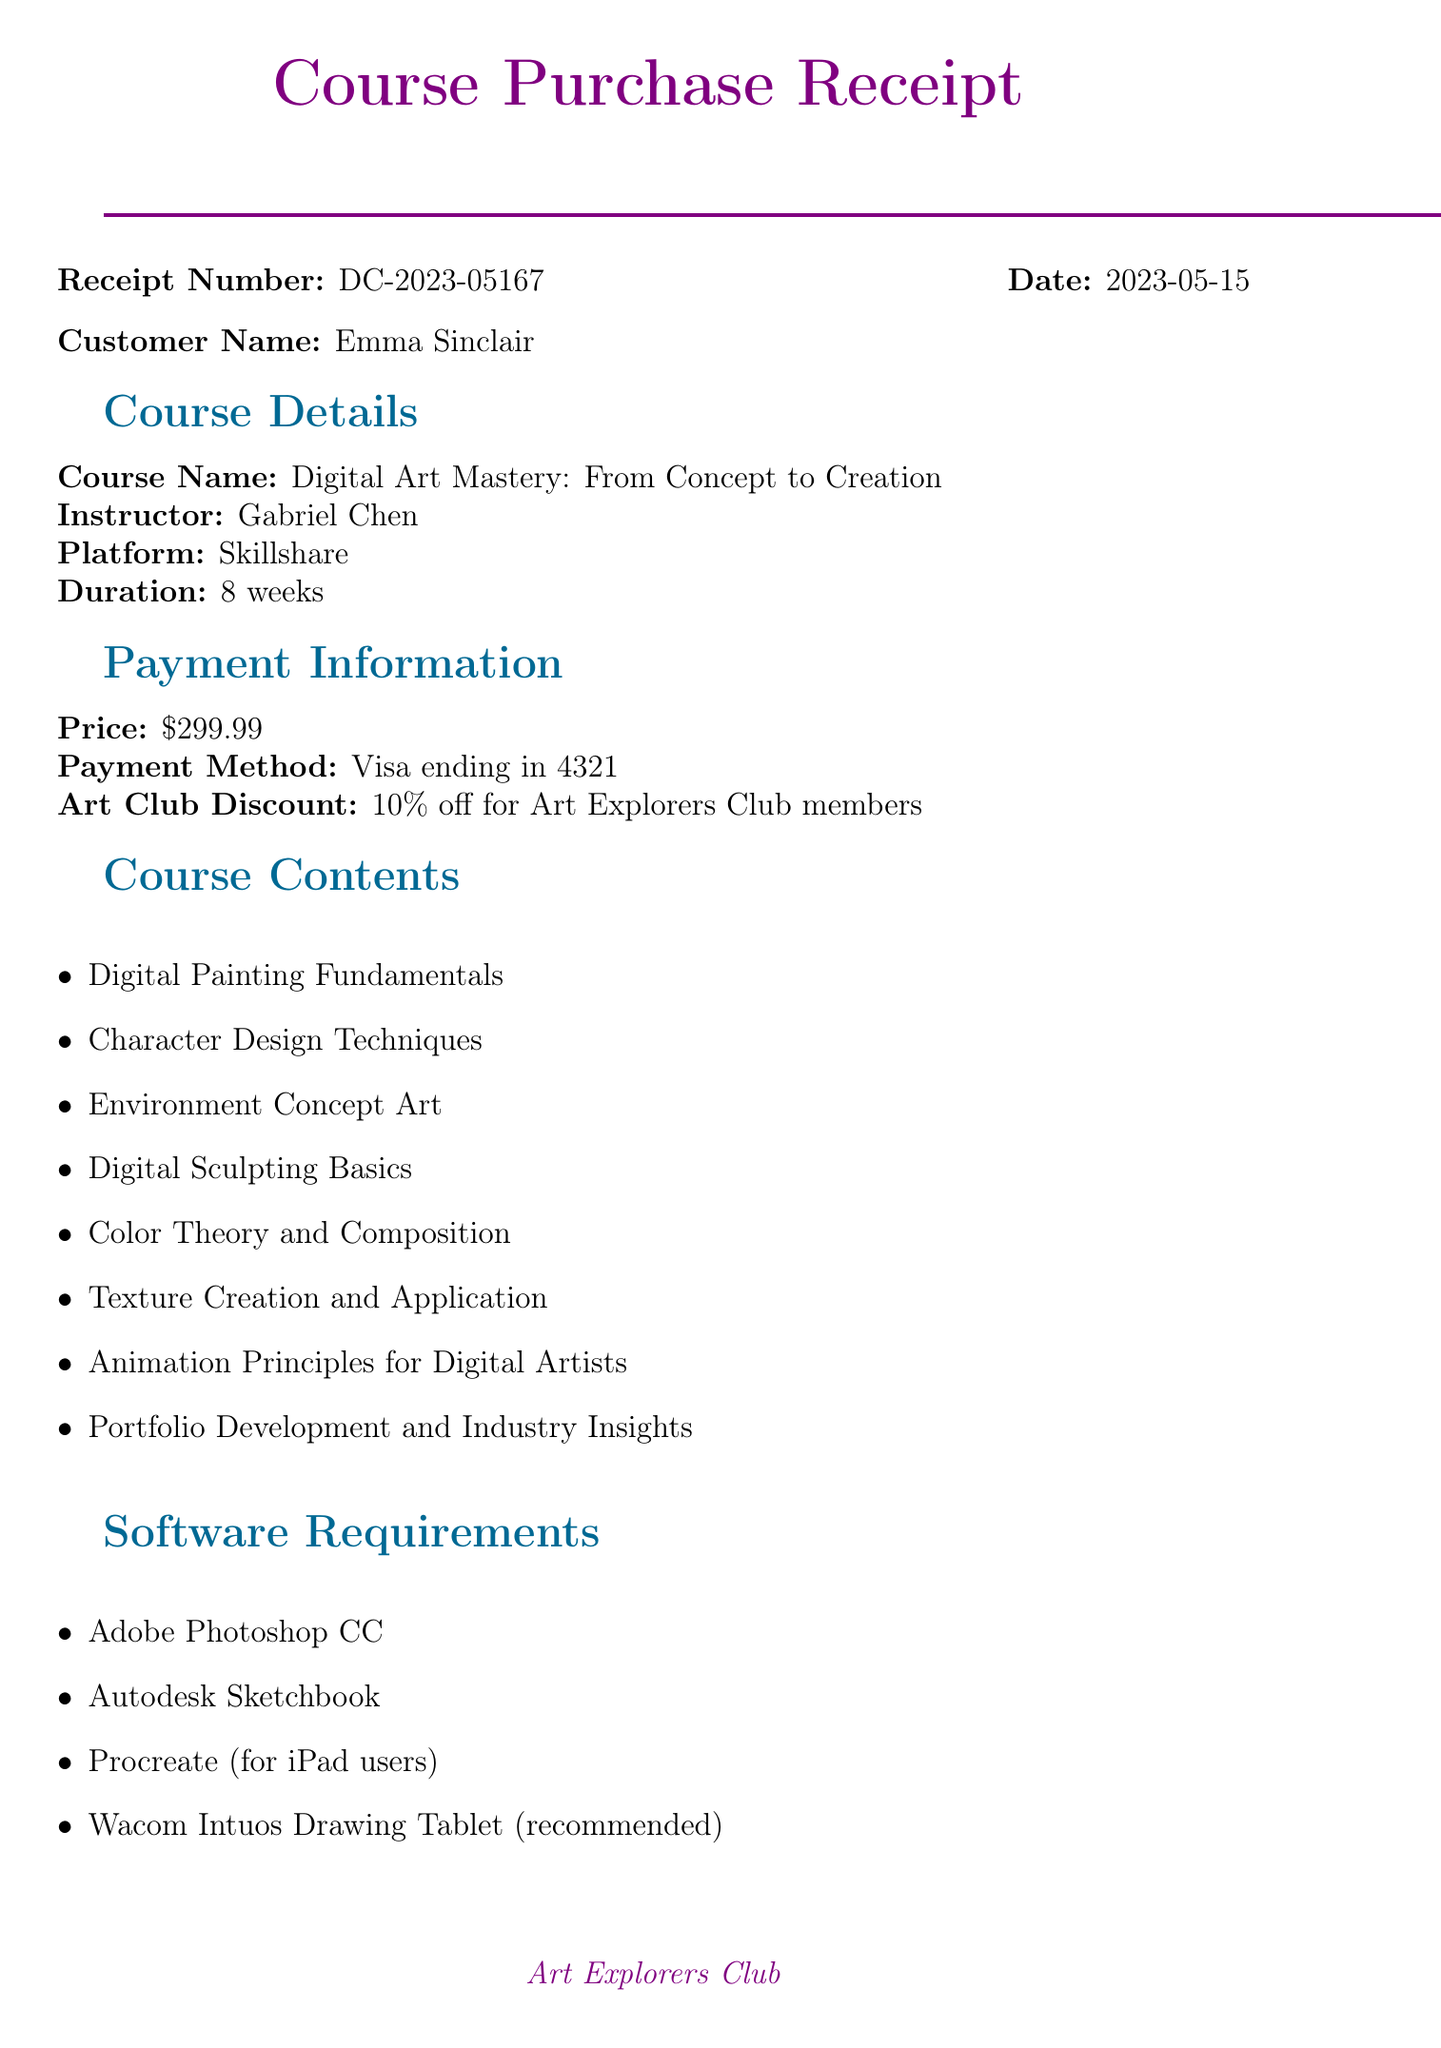What is the receipt number? The receipt number is listed as a unique identifier for the purchase, which is DC-2023-05167.
Answer: DC-2023-05167 Who is the instructor for the course? The instructor's name is explicitly mentioned in the course details section, which is Gabriel Chen.
Answer: Gabriel Chen What is the price of the course? The price of the course is provided in the payment information section, which is $299.99.
Answer: $299.99 How long is the course duration? The duration of the course is stated in the course details, which is 8 weeks.
Answer: 8 weeks What software is recommended for the course? The software requirements section lists the applications needed, one of which is Adobe Photoshop CC.
Answer: Adobe Photoshop CC What discount do Art Explorers Club members receive? The document states the discount for club members in the payment information, which is 10%.
Answer: 10% How can you access the course? Access instructions detail the steps to take, starting with logging into Skillshare.
Answer: Log in to your Skillshare account at www.skillshare.com Is there a refund policy? The refund policy is mentioned in the document, confirming there is a 14-day money-back guarantee.
Answer: 14-day money-back guarantee What bonus material is included? The bonus materials are listed in a specific section, including an exclusive digital brushes set.
Answer: Exclusive digital brushes set 